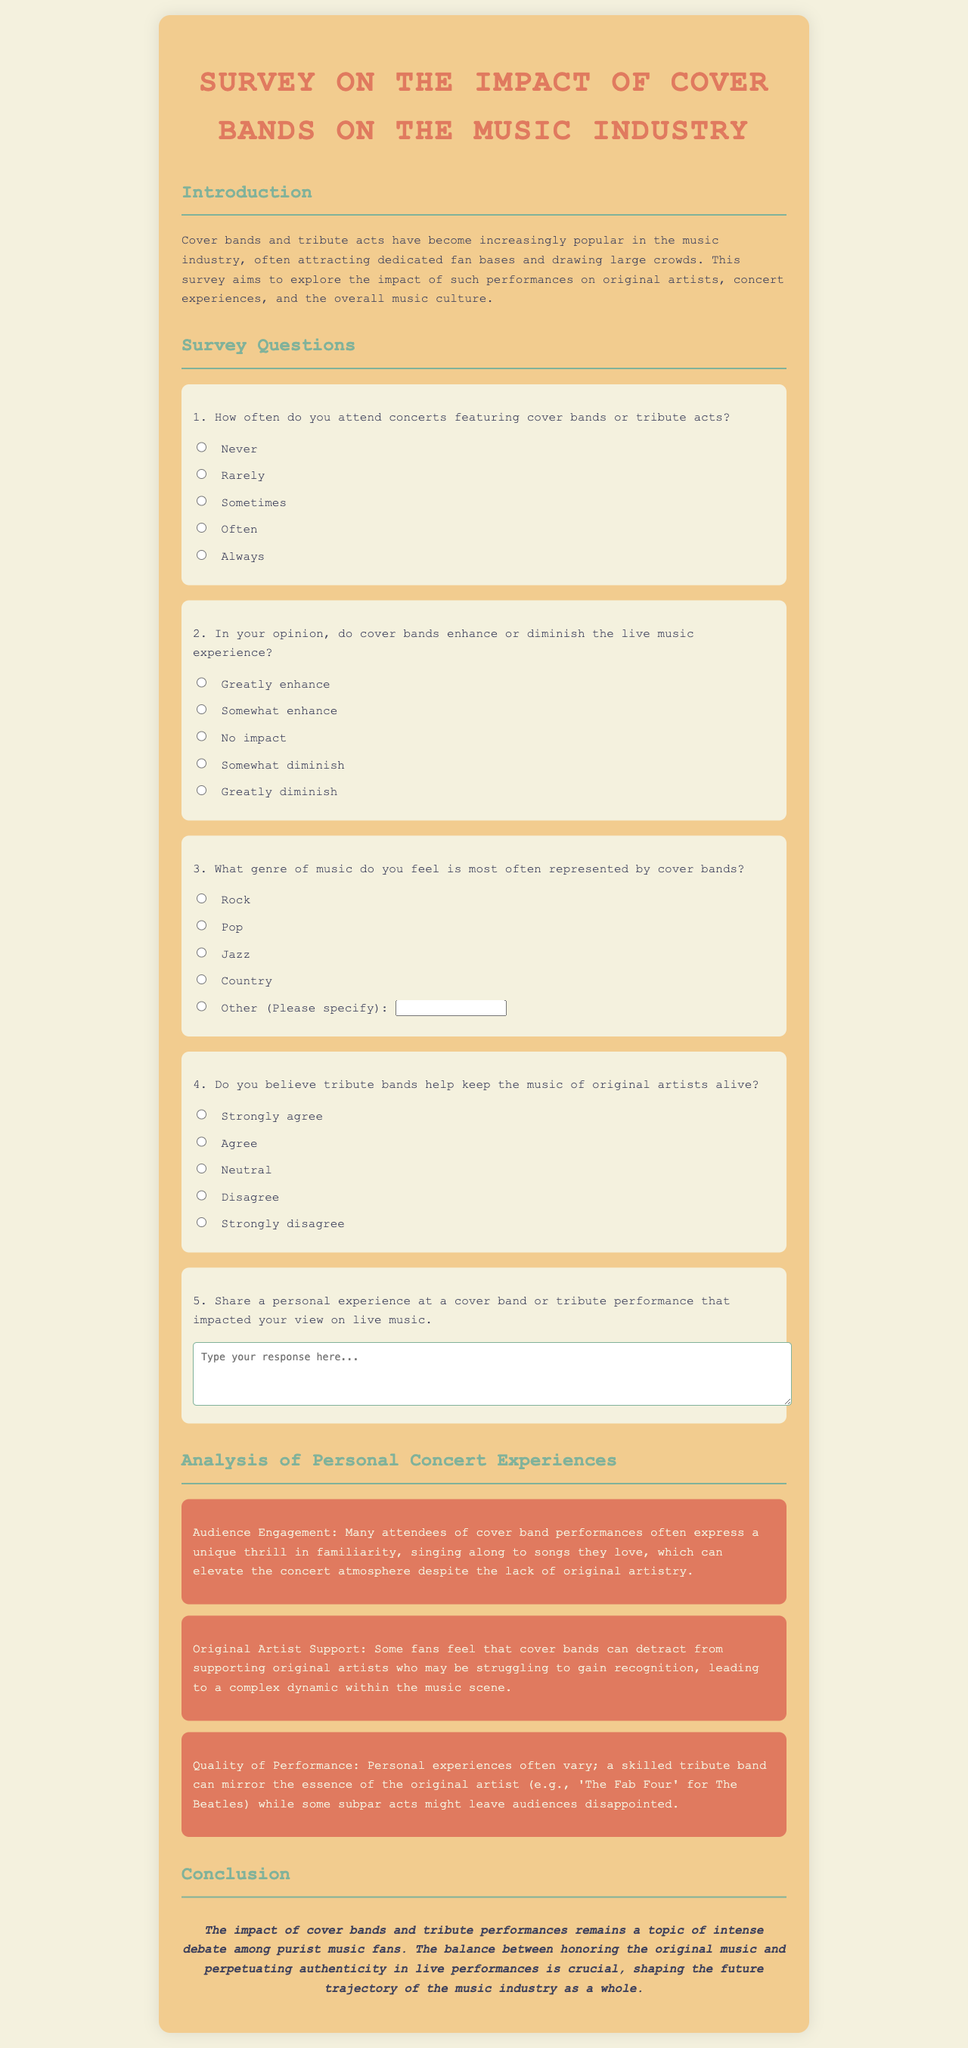What is the title of the survey? The title of the survey is stated at the top of the document.
Answer: Survey on the Impact of Cover Bands What does section two of the document focus on? Section two of the document is dedicated to collecting information from respondents.
Answer: Survey Questions How many options are provided for the frequency of attending cover band concerts? The options available for concert frequency are listed in multiple-choice format.
Answer: Five What is the main conclusion about cover bands mentioned in the last section? The conclusion summarizes the perspectives on cover bands and their authenticity in live performances.
Answer: The impact of cover bands and tribute performances remains a topic of intense debate among purist music fans Which genre is most often represented by cover bands according to the survey? The survey provides a set of genres and allows respondents to select one.
Answer: Rock What is one aspect that attendees experience at cover band performances? This aspect highlights the emotional engagement of audiences during performances.
Answer: Audience Engagement How does the document classify the opinion on whether tribute bands support original artists? The survey asks respondents to express their agreement or disagreement with the support role of tribute bands.
Answer: Original Artist Support What is the required length for responses to personal experiences shared in the survey? The document specifies a space for respondent reflections.
Answer: Four rows 